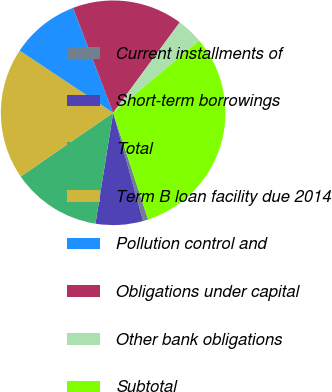<chart> <loc_0><loc_0><loc_500><loc_500><pie_chart><fcel>Current installments of<fcel>Short-term borrowings<fcel>Total<fcel>Term B loan facility due 2014<fcel>Pollution control and<fcel>Obligations under capital<fcel>Other bank obligations<fcel>Subtotal<nl><fcel>0.75%<fcel>6.81%<fcel>12.88%<fcel>18.94%<fcel>9.85%<fcel>15.91%<fcel>3.78%<fcel>31.07%<nl></chart> 